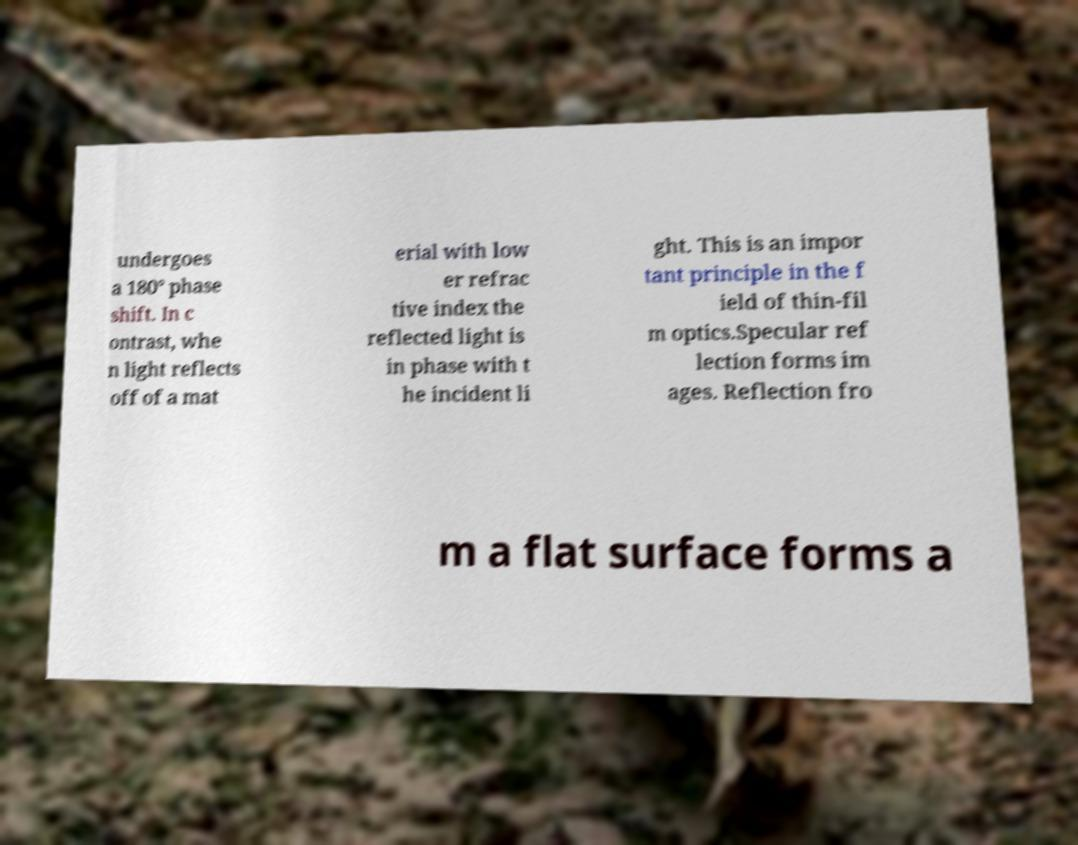Can you accurately transcribe the text from the provided image for me? undergoes a 180° phase shift. In c ontrast, whe n light reflects off of a mat erial with low er refrac tive index the reflected light is in phase with t he incident li ght. This is an impor tant principle in the f ield of thin-fil m optics.Specular ref lection forms im ages. Reflection fro m a flat surface forms a 